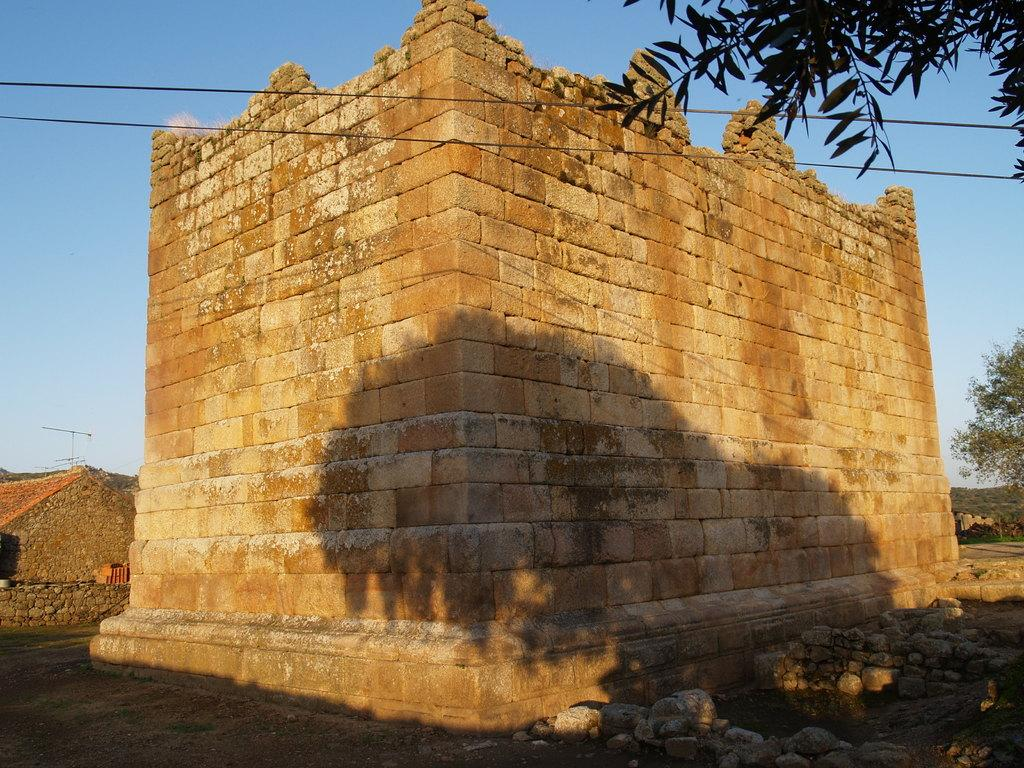What can be seen in the sky in the image? The sky with clouds is visible in the image. What type of natural vegetation is present in the image? There are trees in the image. What type of infrastructure is present in the image? Cables, a road, and buildings are visible in the image. What type of terrain is present in the image? Stones on the ground are present in the image. Can you see the seashore in the image? No, there is no seashore present in the image. What type of card is being used by the person in the image? There is no person or card present in the image. 